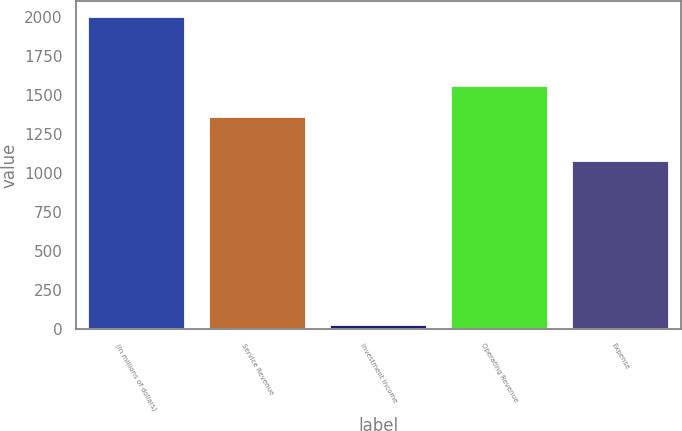Convert chart to OTSL. <chart><loc_0><loc_0><loc_500><loc_500><bar_chart><fcel>(In millions of dollars)<fcel>Service Revenue<fcel>Investment Income<fcel>Operating Revenue<fcel>Expense<nl><fcel>2006<fcel>1360<fcel>25<fcel>1558.1<fcel>1082<nl></chart> 